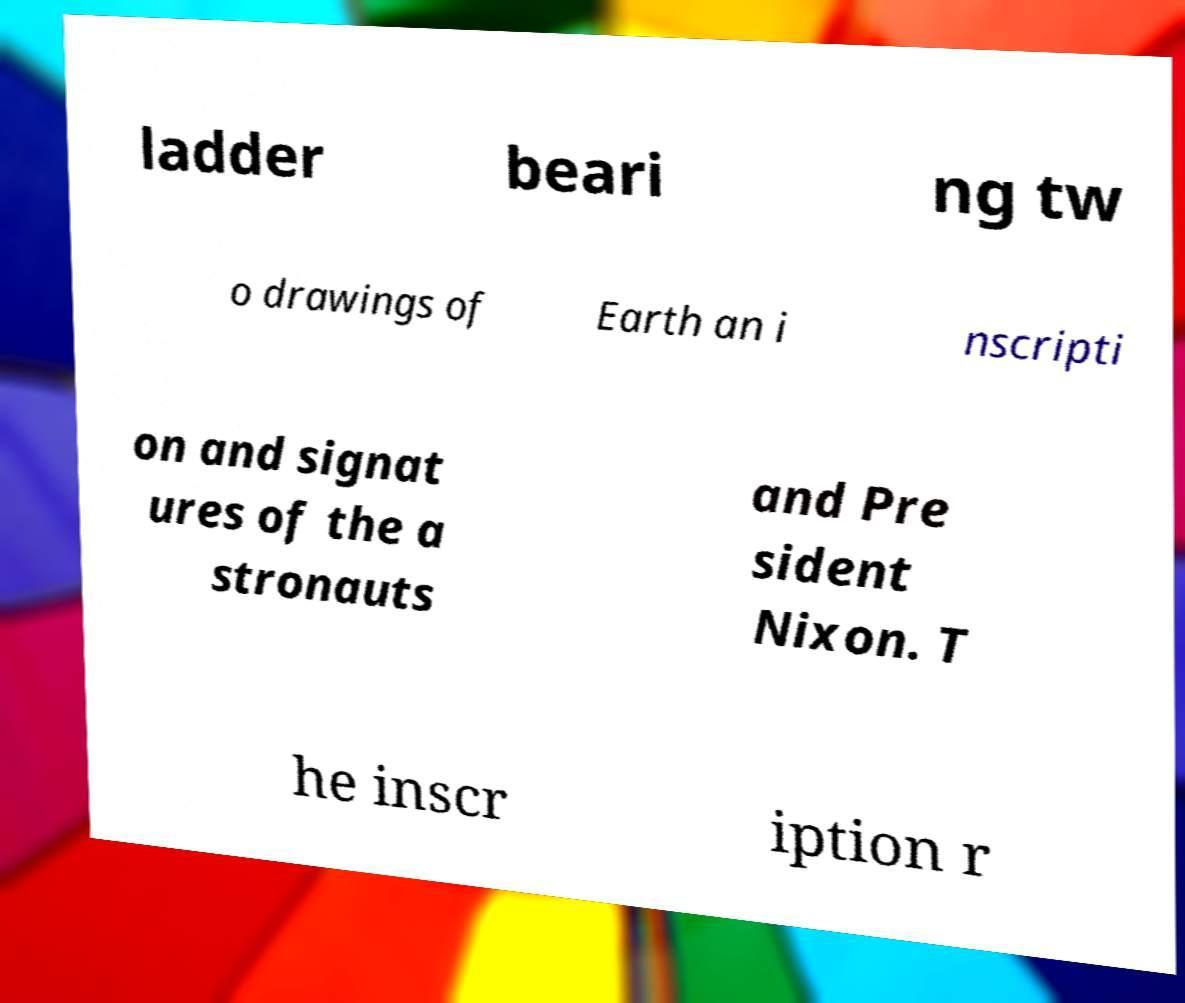For documentation purposes, I need the text within this image transcribed. Could you provide that? ladder beari ng tw o drawings of Earth an i nscripti on and signat ures of the a stronauts and Pre sident Nixon. T he inscr iption r 